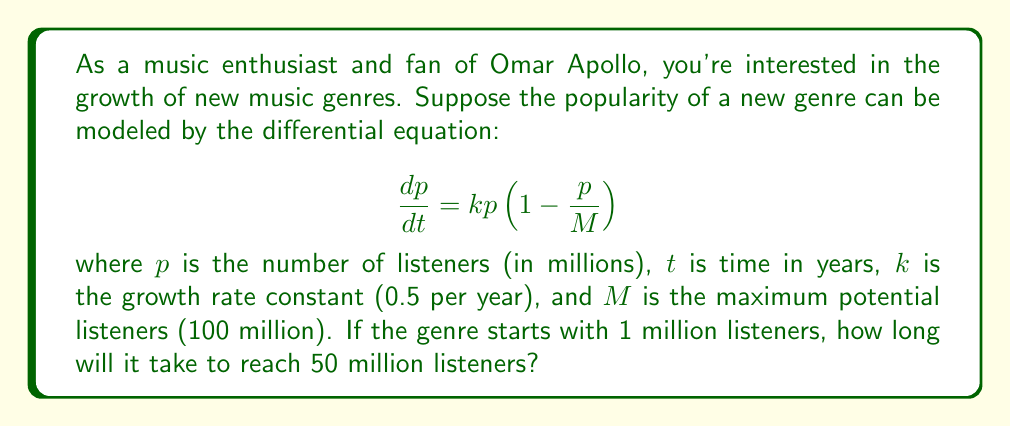Could you help me with this problem? To solve this problem, we need to use the logistic growth model, which is a first-order differential equation. Let's approach this step-by-step:

1) The given differential equation is:

   $$\frac{dp}{dt} = kp(1-\frac{p}{M})$$

2) This is a separable equation. We can separate the variables:

   $$\frac{dp}{p(1-\frac{p}{M})} = kdt$$

3) Integrating both sides:

   $$\int \frac{dp}{p(1-\frac{p}{M})} = \int kdt$$

4) The left side can be integrated using partial fractions:

   $$\ln|p| - \ln|M-p| = kt + C$$

5) Simplifying and solving for $p$:

   $$p = \frac{M}{1 + Ae^{-kt}}$$

   where $A$ is a constant determined by initial conditions.

6) Given $p(0) = 1$ million, we can find $A$:

   $$1 = \frac{100}{1 + A}$$
   $$A = 99$$

7) So our solution is:

   $$p = \frac{100}{1 + 99e^{-0.5t}}$$

8) We want to find $t$ when $p = 50$ million:

   $$50 = \frac{100}{1 + 99e^{-0.5t}}$$

9) Solving for $t$:

   $$1 + 99e^{-0.5t} = 2$$
   $$99e^{-0.5t} = 1$$
   $$e^{-0.5t} = \frac{1}{99}$$
   $$-0.5t = \ln(\frac{1}{99})$$
   $$t = -2\ln(\frac{1}{99}) \approx 9.19$$

Therefore, it will take approximately 9.19 years for the genre to reach 50 million listeners.
Answer: 9.19 years 